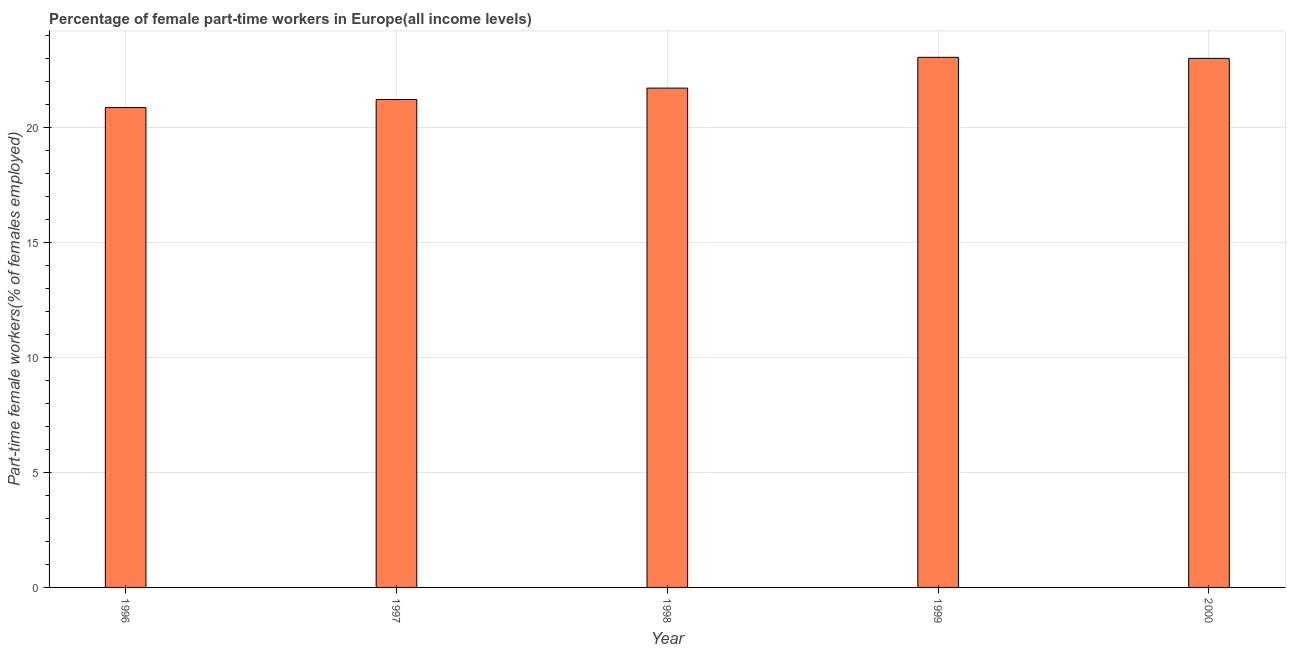Does the graph contain any zero values?
Your answer should be very brief. No. What is the title of the graph?
Provide a succinct answer. Percentage of female part-time workers in Europe(all income levels). What is the label or title of the Y-axis?
Make the answer very short. Part-time female workers(% of females employed). What is the percentage of part-time female workers in 2000?
Offer a terse response. 23. Across all years, what is the maximum percentage of part-time female workers?
Your response must be concise. 23.05. Across all years, what is the minimum percentage of part-time female workers?
Make the answer very short. 20.86. What is the sum of the percentage of part-time female workers?
Make the answer very short. 109.85. What is the difference between the percentage of part-time female workers in 1996 and 2000?
Ensure brevity in your answer.  -2.14. What is the average percentage of part-time female workers per year?
Give a very brief answer. 21.97. What is the median percentage of part-time female workers?
Make the answer very short. 21.71. In how many years, is the percentage of part-time female workers greater than 11 %?
Your response must be concise. 5. What is the ratio of the percentage of part-time female workers in 1996 to that in 1997?
Give a very brief answer. 0.98. Is the percentage of part-time female workers in 1998 less than that in 1999?
Offer a terse response. Yes. What is the difference between the highest and the second highest percentage of part-time female workers?
Give a very brief answer. 0.04. What is the difference between the highest and the lowest percentage of part-time female workers?
Your response must be concise. 2.19. In how many years, is the percentage of part-time female workers greater than the average percentage of part-time female workers taken over all years?
Keep it short and to the point. 2. Are all the bars in the graph horizontal?
Make the answer very short. No. What is the difference between two consecutive major ticks on the Y-axis?
Provide a succinct answer. 5. What is the Part-time female workers(% of females employed) of 1996?
Offer a very short reply. 20.86. What is the Part-time female workers(% of females employed) in 1997?
Your answer should be compact. 21.22. What is the Part-time female workers(% of females employed) in 1998?
Make the answer very short. 21.71. What is the Part-time female workers(% of females employed) in 1999?
Your answer should be very brief. 23.05. What is the Part-time female workers(% of females employed) in 2000?
Your answer should be compact. 23. What is the difference between the Part-time female workers(% of females employed) in 1996 and 1997?
Your response must be concise. -0.35. What is the difference between the Part-time female workers(% of females employed) in 1996 and 1998?
Make the answer very short. -0.85. What is the difference between the Part-time female workers(% of females employed) in 1996 and 1999?
Provide a short and direct response. -2.19. What is the difference between the Part-time female workers(% of females employed) in 1996 and 2000?
Your response must be concise. -2.14. What is the difference between the Part-time female workers(% of females employed) in 1997 and 1998?
Provide a succinct answer. -0.5. What is the difference between the Part-time female workers(% of females employed) in 1997 and 1999?
Your answer should be very brief. -1.83. What is the difference between the Part-time female workers(% of females employed) in 1997 and 2000?
Make the answer very short. -1.79. What is the difference between the Part-time female workers(% of females employed) in 1998 and 1999?
Offer a very short reply. -1.34. What is the difference between the Part-time female workers(% of females employed) in 1998 and 2000?
Give a very brief answer. -1.29. What is the difference between the Part-time female workers(% of females employed) in 1999 and 2000?
Provide a succinct answer. 0.04. What is the ratio of the Part-time female workers(% of females employed) in 1996 to that in 1998?
Provide a short and direct response. 0.96. What is the ratio of the Part-time female workers(% of females employed) in 1996 to that in 1999?
Offer a very short reply. 0.91. What is the ratio of the Part-time female workers(% of females employed) in 1996 to that in 2000?
Provide a succinct answer. 0.91. What is the ratio of the Part-time female workers(% of females employed) in 1997 to that in 1998?
Give a very brief answer. 0.98. What is the ratio of the Part-time female workers(% of females employed) in 1997 to that in 2000?
Keep it short and to the point. 0.92. What is the ratio of the Part-time female workers(% of females employed) in 1998 to that in 1999?
Provide a short and direct response. 0.94. What is the ratio of the Part-time female workers(% of females employed) in 1998 to that in 2000?
Your answer should be very brief. 0.94. 